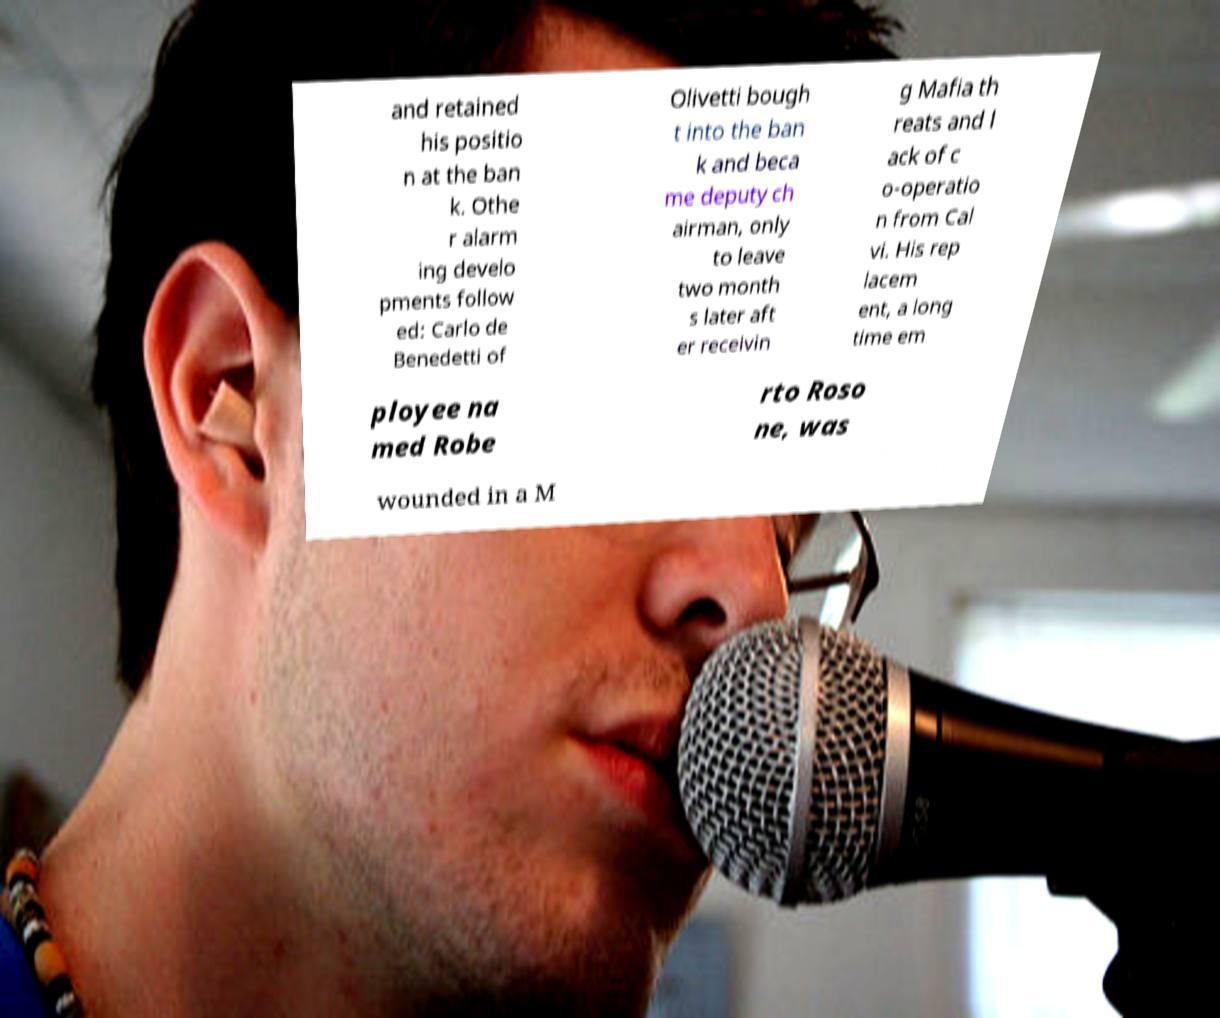Can you accurately transcribe the text from the provided image for me? and retained his positio n at the ban k. Othe r alarm ing develo pments follow ed: Carlo de Benedetti of Olivetti bough t into the ban k and beca me deputy ch airman, only to leave two month s later aft er receivin g Mafia th reats and l ack of c o-operatio n from Cal vi. His rep lacem ent, a long time em ployee na med Robe rto Roso ne, was wounded in a M 